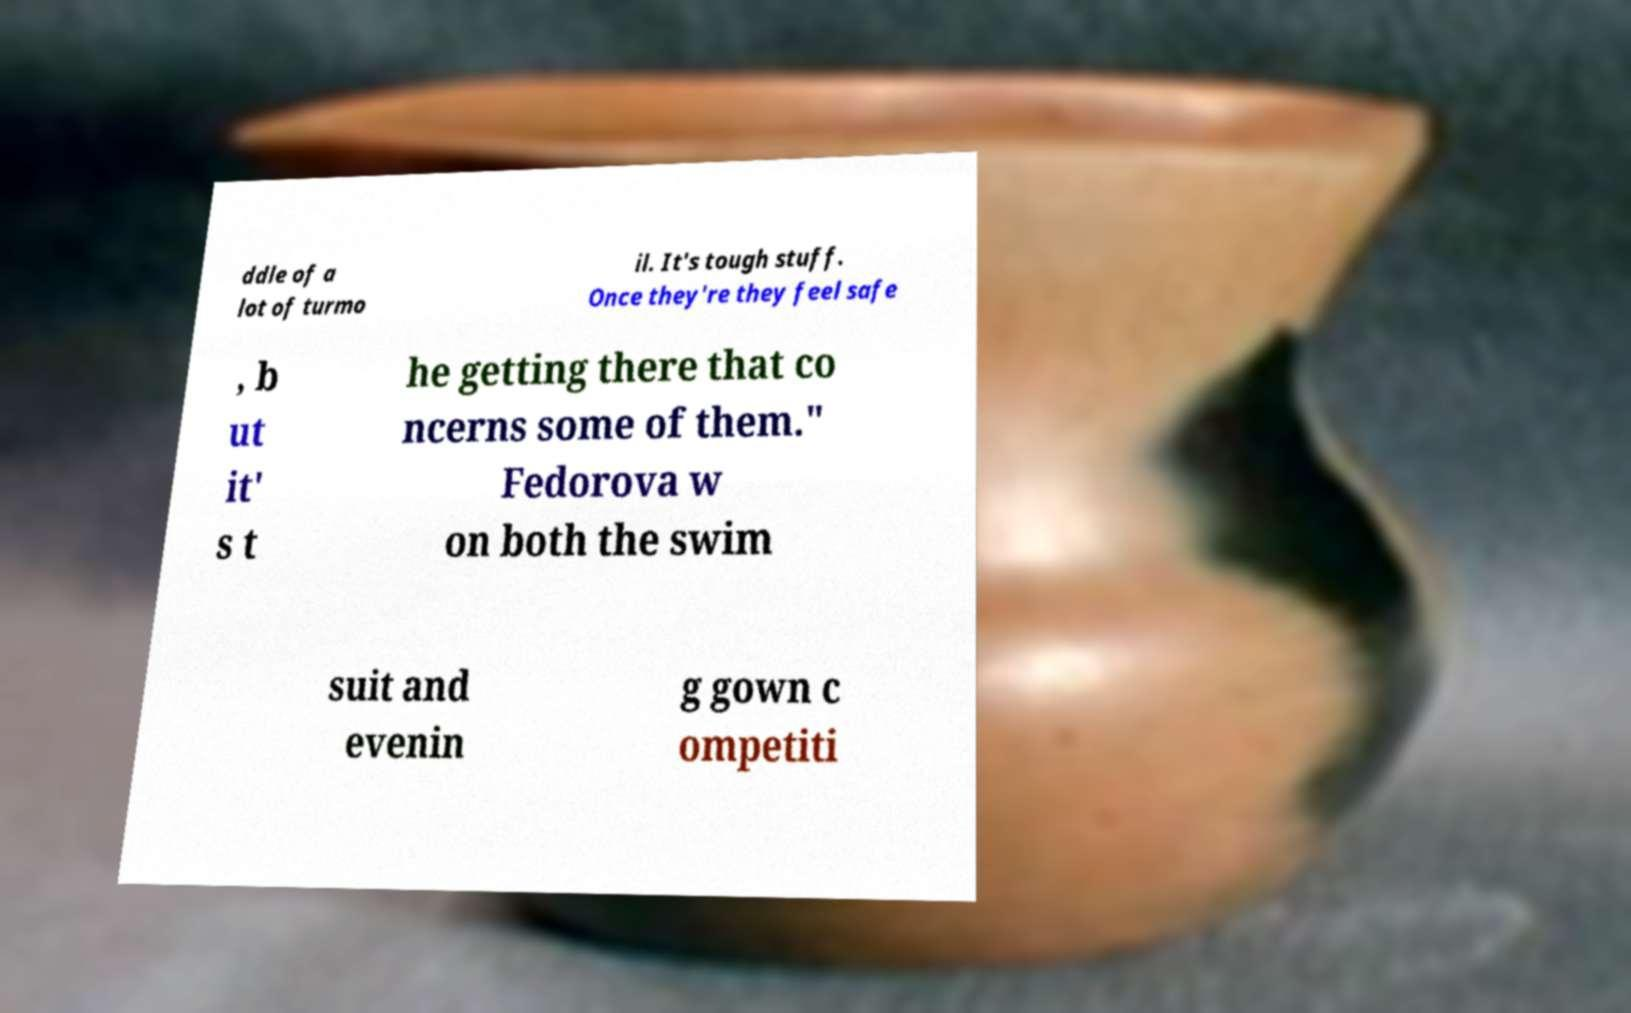Could you assist in decoding the text presented in this image and type it out clearly? ddle of a lot of turmo il. It's tough stuff. Once they're they feel safe , b ut it' s t he getting there that co ncerns some of them." Fedorova w on both the swim suit and evenin g gown c ompetiti 